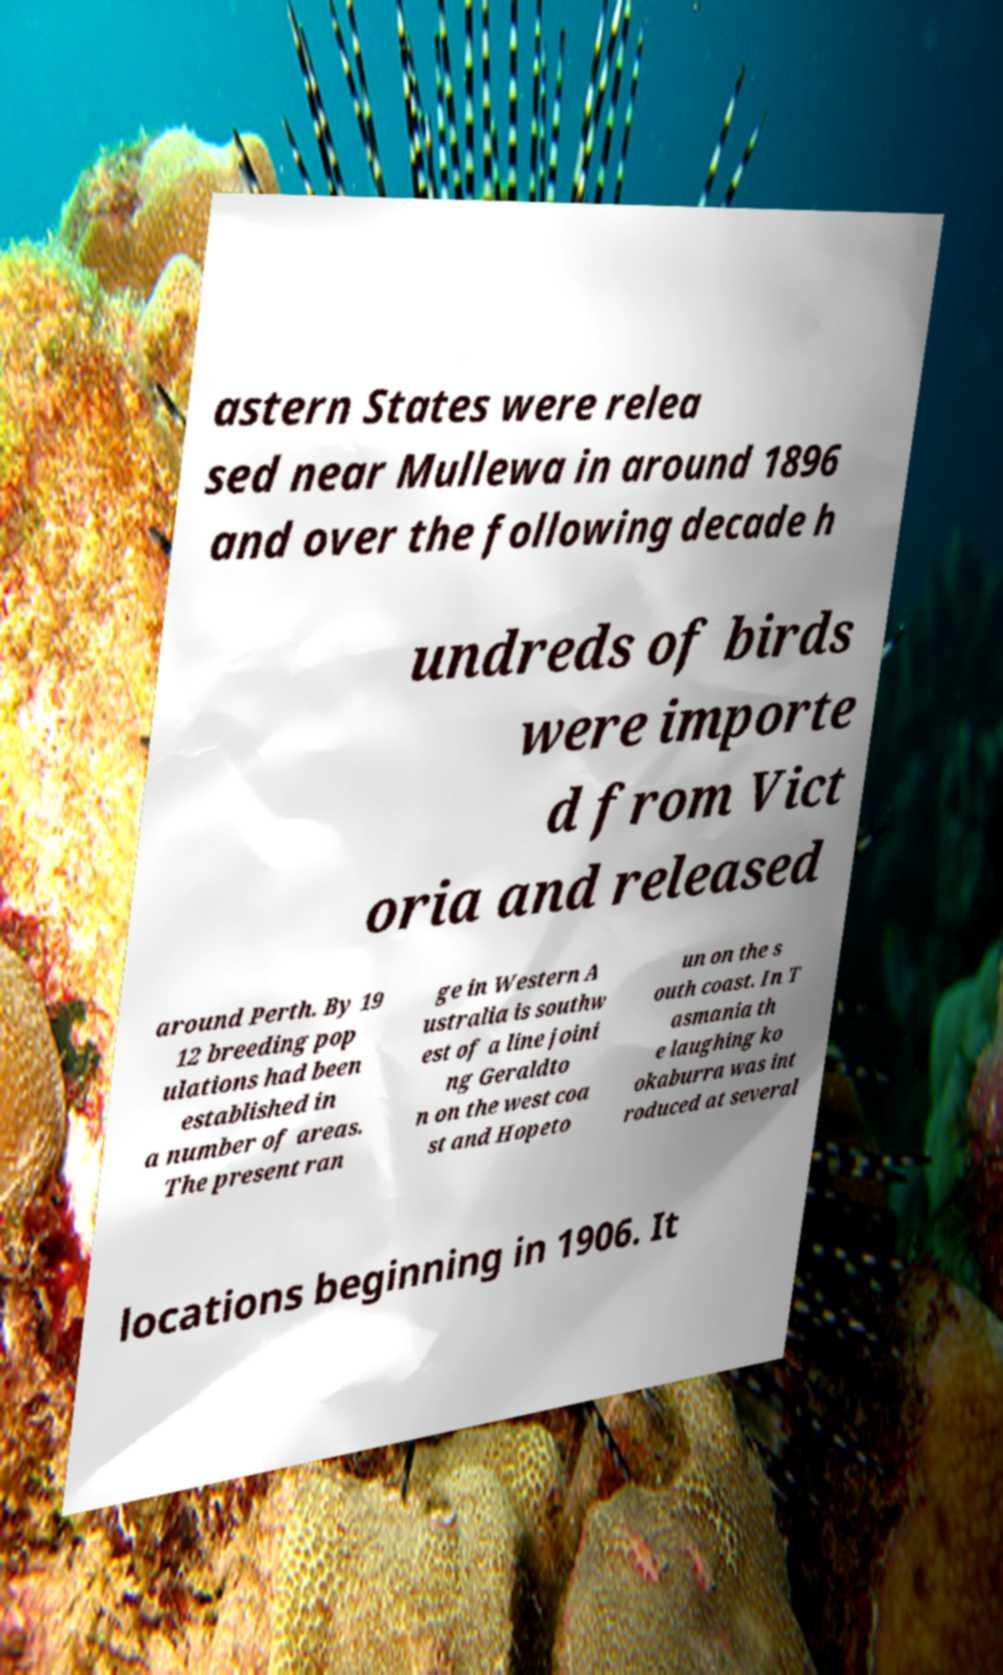For documentation purposes, I need the text within this image transcribed. Could you provide that? astern States were relea sed near Mullewa in around 1896 and over the following decade h undreds of birds were importe d from Vict oria and released around Perth. By 19 12 breeding pop ulations had been established in a number of areas. The present ran ge in Western A ustralia is southw est of a line joini ng Geraldto n on the west coa st and Hopeto un on the s outh coast. In T asmania th e laughing ko okaburra was int roduced at several locations beginning in 1906. It 